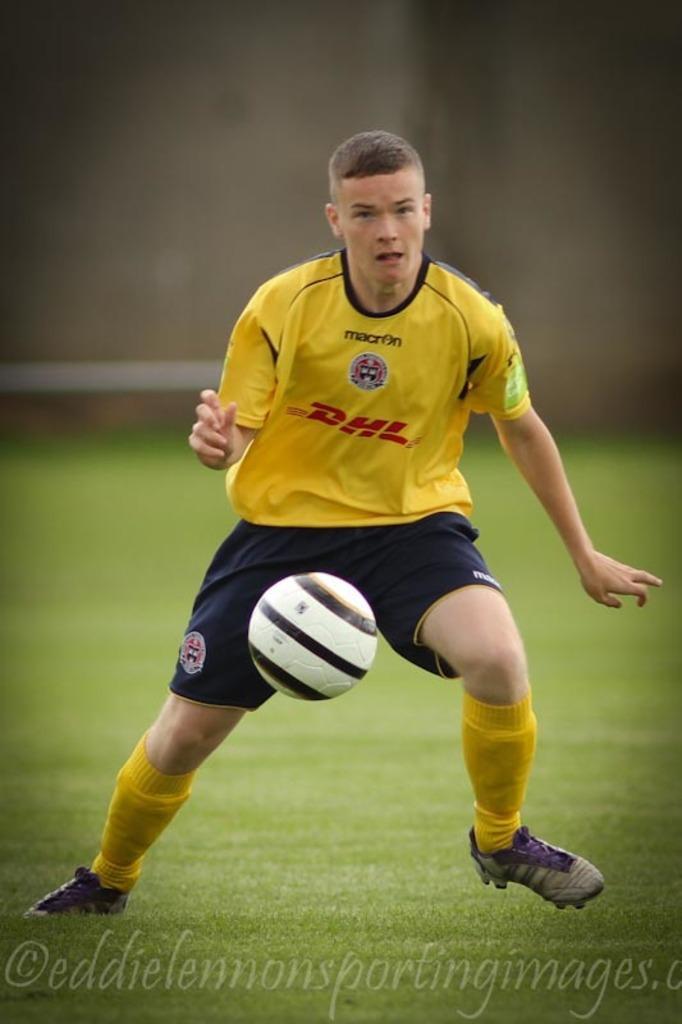Please provide a concise description of this image. In this picture we can see a man, he wore a t-shirt, shorts and shoes, at the bottom there is grass, we can also see text at the bottom, in the background there is a wall, we can see a ball in the middle. 